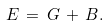<formula> <loc_0><loc_0><loc_500><loc_500>E \, = \, G \, + \, B .</formula> 